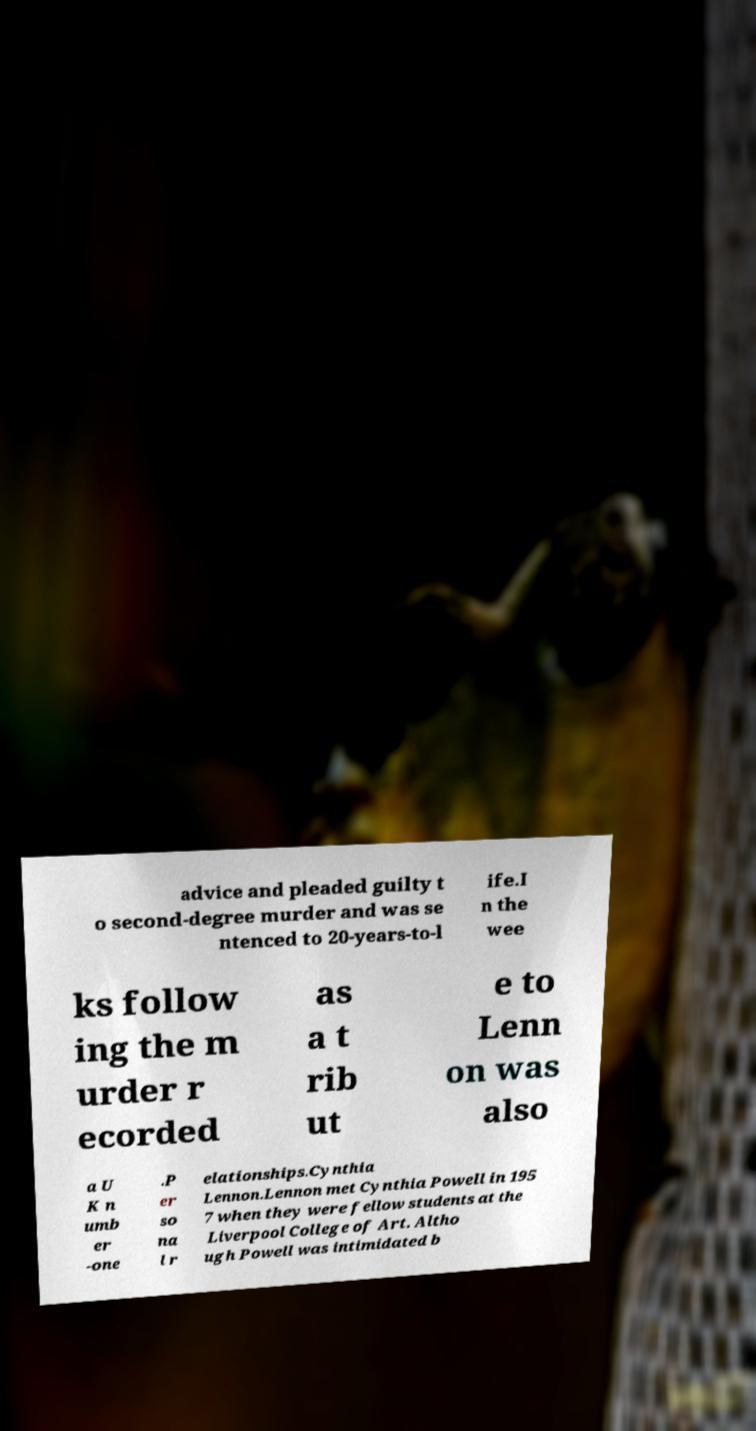Please identify and transcribe the text found in this image. advice and pleaded guilty t o second-degree murder and was se ntenced to 20-years-to-l ife.I n the wee ks follow ing the m urder r ecorded as a t rib ut e to Lenn on was also a U K n umb er -one .P er so na l r elationships.Cynthia Lennon.Lennon met Cynthia Powell in 195 7 when they were fellow students at the Liverpool College of Art. Altho ugh Powell was intimidated b 